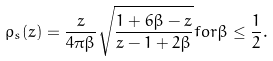Convert formula to latex. <formula><loc_0><loc_0><loc_500><loc_500>\rho _ { s } ( z ) = \frac { z } { 4 \pi \beta } \sqrt { \frac { 1 + 6 \beta - z } { z - 1 + 2 \beta } } f o r \beta \leq \frac { 1 } { 2 } .</formula> 